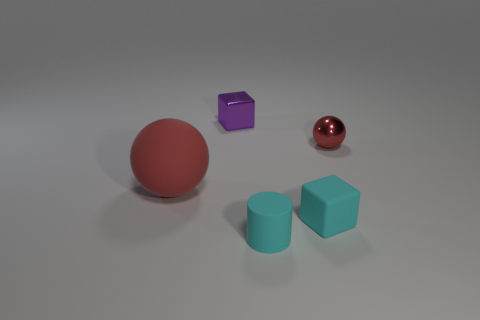Does the small red metallic object have the same shape as the large matte object? yes 